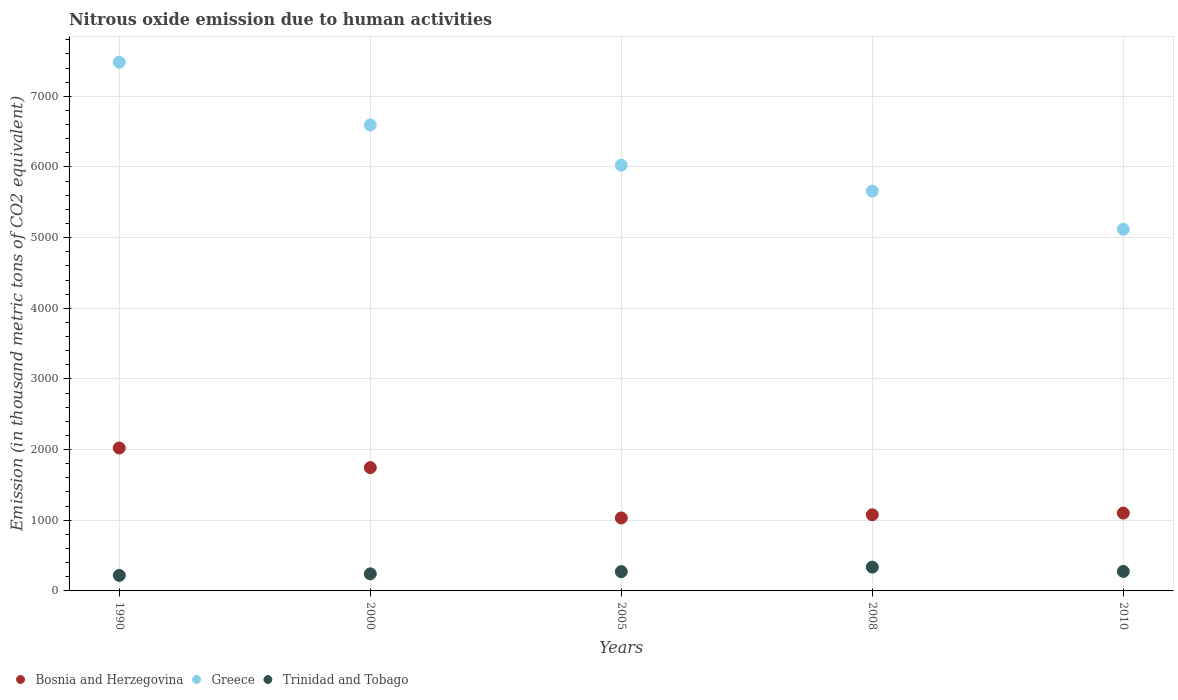How many different coloured dotlines are there?
Your answer should be compact. 3. Is the number of dotlines equal to the number of legend labels?
Make the answer very short. Yes. What is the amount of nitrous oxide emitted in Greece in 2000?
Your response must be concise. 6594. Across all years, what is the maximum amount of nitrous oxide emitted in Trinidad and Tobago?
Ensure brevity in your answer.  336.8. Across all years, what is the minimum amount of nitrous oxide emitted in Bosnia and Herzegovina?
Your answer should be compact. 1032.3. In which year was the amount of nitrous oxide emitted in Trinidad and Tobago minimum?
Keep it short and to the point. 1990. What is the total amount of nitrous oxide emitted in Trinidad and Tobago in the graph?
Provide a succinct answer. 1346.8. What is the difference between the amount of nitrous oxide emitted in Trinidad and Tobago in 1990 and that in 2008?
Provide a short and direct response. -116.9. What is the difference between the amount of nitrous oxide emitted in Trinidad and Tobago in 1990 and the amount of nitrous oxide emitted in Bosnia and Herzegovina in 2000?
Your answer should be very brief. -1525. What is the average amount of nitrous oxide emitted in Bosnia and Herzegovina per year?
Provide a short and direct response. 1395.78. In the year 2005, what is the difference between the amount of nitrous oxide emitted in Bosnia and Herzegovina and amount of nitrous oxide emitted in Trinidad and Tobago?
Your answer should be compact. 759.5. In how many years, is the amount of nitrous oxide emitted in Trinidad and Tobago greater than 7600 thousand metric tons?
Your answer should be compact. 0. What is the ratio of the amount of nitrous oxide emitted in Trinidad and Tobago in 2005 to that in 2010?
Give a very brief answer. 0.99. Is the amount of nitrous oxide emitted in Bosnia and Herzegovina in 2008 less than that in 2010?
Ensure brevity in your answer.  Yes. Is the difference between the amount of nitrous oxide emitted in Bosnia and Herzegovina in 1990 and 2008 greater than the difference between the amount of nitrous oxide emitted in Trinidad and Tobago in 1990 and 2008?
Give a very brief answer. Yes. What is the difference between the highest and the second highest amount of nitrous oxide emitted in Bosnia and Herzegovina?
Keep it short and to the point. 277.7. What is the difference between the highest and the lowest amount of nitrous oxide emitted in Greece?
Your response must be concise. 2364.4. In how many years, is the amount of nitrous oxide emitted in Trinidad and Tobago greater than the average amount of nitrous oxide emitted in Trinidad and Tobago taken over all years?
Make the answer very short. 3. Is the amount of nitrous oxide emitted in Bosnia and Herzegovina strictly greater than the amount of nitrous oxide emitted in Greece over the years?
Offer a very short reply. No. How many dotlines are there?
Keep it short and to the point. 3. How many years are there in the graph?
Ensure brevity in your answer.  5. What is the difference between two consecutive major ticks on the Y-axis?
Your answer should be very brief. 1000. Are the values on the major ticks of Y-axis written in scientific E-notation?
Your answer should be compact. No. Does the graph contain grids?
Your answer should be very brief. Yes. How are the legend labels stacked?
Offer a terse response. Horizontal. What is the title of the graph?
Provide a short and direct response. Nitrous oxide emission due to human activities. Does "Monaco" appear as one of the legend labels in the graph?
Make the answer very short. No. What is the label or title of the Y-axis?
Keep it short and to the point. Emission (in thousand metric tons of CO2 equivalent). What is the Emission (in thousand metric tons of CO2 equivalent) of Bosnia and Herzegovina in 1990?
Keep it short and to the point. 2022.6. What is the Emission (in thousand metric tons of CO2 equivalent) in Greece in 1990?
Give a very brief answer. 7482.2. What is the Emission (in thousand metric tons of CO2 equivalent) in Trinidad and Tobago in 1990?
Offer a terse response. 219.9. What is the Emission (in thousand metric tons of CO2 equivalent) of Bosnia and Herzegovina in 2000?
Provide a succinct answer. 1744.9. What is the Emission (in thousand metric tons of CO2 equivalent) of Greece in 2000?
Offer a terse response. 6594. What is the Emission (in thousand metric tons of CO2 equivalent) of Trinidad and Tobago in 2000?
Your answer should be very brief. 241.5. What is the Emission (in thousand metric tons of CO2 equivalent) in Bosnia and Herzegovina in 2005?
Ensure brevity in your answer.  1032.3. What is the Emission (in thousand metric tons of CO2 equivalent) of Greece in 2005?
Ensure brevity in your answer.  6025. What is the Emission (in thousand metric tons of CO2 equivalent) of Trinidad and Tobago in 2005?
Your answer should be compact. 272.8. What is the Emission (in thousand metric tons of CO2 equivalent) of Bosnia and Herzegovina in 2008?
Offer a very short reply. 1077.6. What is the Emission (in thousand metric tons of CO2 equivalent) in Greece in 2008?
Make the answer very short. 5657.7. What is the Emission (in thousand metric tons of CO2 equivalent) in Trinidad and Tobago in 2008?
Your answer should be very brief. 336.8. What is the Emission (in thousand metric tons of CO2 equivalent) of Bosnia and Herzegovina in 2010?
Ensure brevity in your answer.  1101.5. What is the Emission (in thousand metric tons of CO2 equivalent) of Greece in 2010?
Provide a short and direct response. 5117.8. What is the Emission (in thousand metric tons of CO2 equivalent) of Trinidad and Tobago in 2010?
Your response must be concise. 275.8. Across all years, what is the maximum Emission (in thousand metric tons of CO2 equivalent) of Bosnia and Herzegovina?
Keep it short and to the point. 2022.6. Across all years, what is the maximum Emission (in thousand metric tons of CO2 equivalent) of Greece?
Keep it short and to the point. 7482.2. Across all years, what is the maximum Emission (in thousand metric tons of CO2 equivalent) of Trinidad and Tobago?
Your response must be concise. 336.8. Across all years, what is the minimum Emission (in thousand metric tons of CO2 equivalent) of Bosnia and Herzegovina?
Make the answer very short. 1032.3. Across all years, what is the minimum Emission (in thousand metric tons of CO2 equivalent) of Greece?
Give a very brief answer. 5117.8. Across all years, what is the minimum Emission (in thousand metric tons of CO2 equivalent) of Trinidad and Tobago?
Offer a very short reply. 219.9. What is the total Emission (in thousand metric tons of CO2 equivalent) in Bosnia and Herzegovina in the graph?
Provide a succinct answer. 6978.9. What is the total Emission (in thousand metric tons of CO2 equivalent) in Greece in the graph?
Give a very brief answer. 3.09e+04. What is the total Emission (in thousand metric tons of CO2 equivalent) in Trinidad and Tobago in the graph?
Provide a succinct answer. 1346.8. What is the difference between the Emission (in thousand metric tons of CO2 equivalent) of Bosnia and Herzegovina in 1990 and that in 2000?
Your answer should be very brief. 277.7. What is the difference between the Emission (in thousand metric tons of CO2 equivalent) in Greece in 1990 and that in 2000?
Your response must be concise. 888.2. What is the difference between the Emission (in thousand metric tons of CO2 equivalent) in Trinidad and Tobago in 1990 and that in 2000?
Offer a terse response. -21.6. What is the difference between the Emission (in thousand metric tons of CO2 equivalent) in Bosnia and Herzegovina in 1990 and that in 2005?
Keep it short and to the point. 990.3. What is the difference between the Emission (in thousand metric tons of CO2 equivalent) of Greece in 1990 and that in 2005?
Offer a terse response. 1457.2. What is the difference between the Emission (in thousand metric tons of CO2 equivalent) of Trinidad and Tobago in 1990 and that in 2005?
Your answer should be compact. -52.9. What is the difference between the Emission (in thousand metric tons of CO2 equivalent) of Bosnia and Herzegovina in 1990 and that in 2008?
Give a very brief answer. 945. What is the difference between the Emission (in thousand metric tons of CO2 equivalent) of Greece in 1990 and that in 2008?
Keep it short and to the point. 1824.5. What is the difference between the Emission (in thousand metric tons of CO2 equivalent) of Trinidad and Tobago in 1990 and that in 2008?
Give a very brief answer. -116.9. What is the difference between the Emission (in thousand metric tons of CO2 equivalent) in Bosnia and Herzegovina in 1990 and that in 2010?
Provide a succinct answer. 921.1. What is the difference between the Emission (in thousand metric tons of CO2 equivalent) in Greece in 1990 and that in 2010?
Make the answer very short. 2364.4. What is the difference between the Emission (in thousand metric tons of CO2 equivalent) in Trinidad and Tobago in 1990 and that in 2010?
Give a very brief answer. -55.9. What is the difference between the Emission (in thousand metric tons of CO2 equivalent) of Bosnia and Herzegovina in 2000 and that in 2005?
Keep it short and to the point. 712.6. What is the difference between the Emission (in thousand metric tons of CO2 equivalent) in Greece in 2000 and that in 2005?
Provide a succinct answer. 569. What is the difference between the Emission (in thousand metric tons of CO2 equivalent) of Trinidad and Tobago in 2000 and that in 2005?
Offer a very short reply. -31.3. What is the difference between the Emission (in thousand metric tons of CO2 equivalent) in Bosnia and Herzegovina in 2000 and that in 2008?
Your answer should be compact. 667.3. What is the difference between the Emission (in thousand metric tons of CO2 equivalent) in Greece in 2000 and that in 2008?
Offer a terse response. 936.3. What is the difference between the Emission (in thousand metric tons of CO2 equivalent) of Trinidad and Tobago in 2000 and that in 2008?
Provide a short and direct response. -95.3. What is the difference between the Emission (in thousand metric tons of CO2 equivalent) in Bosnia and Herzegovina in 2000 and that in 2010?
Provide a succinct answer. 643.4. What is the difference between the Emission (in thousand metric tons of CO2 equivalent) in Greece in 2000 and that in 2010?
Your answer should be compact. 1476.2. What is the difference between the Emission (in thousand metric tons of CO2 equivalent) in Trinidad and Tobago in 2000 and that in 2010?
Give a very brief answer. -34.3. What is the difference between the Emission (in thousand metric tons of CO2 equivalent) of Bosnia and Herzegovina in 2005 and that in 2008?
Make the answer very short. -45.3. What is the difference between the Emission (in thousand metric tons of CO2 equivalent) of Greece in 2005 and that in 2008?
Offer a terse response. 367.3. What is the difference between the Emission (in thousand metric tons of CO2 equivalent) in Trinidad and Tobago in 2005 and that in 2008?
Give a very brief answer. -64. What is the difference between the Emission (in thousand metric tons of CO2 equivalent) in Bosnia and Herzegovina in 2005 and that in 2010?
Your response must be concise. -69.2. What is the difference between the Emission (in thousand metric tons of CO2 equivalent) in Greece in 2005 and that in 2010?
Ensure brevity in your answer.  907.2. What is the difference between the Emission (in thousand metric tons of CO2 equivalent) of Trinidad and Tobago in 2005 and that in 2010?
Your answer should be very brief. -3. What is the difference between the Emission (in thousand metric tons of CO2 equivalent) of Bosnia and Herzegovina in 2008 and that in 2010?
Give a very brief answer. -23.9. What is the difference between the Emission (in thousand metric tons of CO2 equivalent) of Greece in 2008 and that in 2010?
Offer a terse response. 539.9. What is the difference between the Emission (in thousand metric tons of CO2 equivalent) in Trinidad and Tobago in 2008 and that in 2010?
Offer a terse response. 61. What is the difference between the Emission (in thousand metric tons of CO2 equivalent) of Bosnia and Herzegovina in 1990 and the Emission (in thousand metric tons of CO2 equivalent) of Greece in 2000?
Make the answer very short. -4571.4. What is the difference between the Emission (in thousand metric tons of CO2 equivalent) of Bosnia and Herzegovina in 1990 and the Emission (in thousand metric tons of CO2 equivalent) of Trinidad and Tobago in 2000?
Ensure brevity in your answer.  1781.1. What is the difference between the Emission (in thousand metric tons of CO2 equivalent) of Greece in 1990 and the Emission (in thousand metric tons of CO2 equivalent) of Trinidad and Tobago in 2000?
Your answer should be compact. 7240.7. What is the difference between the Emission (in thousand metric tons of CO2 equivalent) of Bosnia and Herzegovina in 1990 and the Emission (in thousand metric tons of CO2 equivalent) of Greece in 2005?
Make the answer very short. -4002.4. What is the difference between the Emission (in thousand metric tons of CO2 equivalent) in Bosnia and Herzegovina in 1990 and the Emission (in thousand metric tons of CO2 equivalent) in Trinidad and Tobago in 2005?
Your answer should be compact. 1749.8. What is the difference between the Emission (in thousand metric tons of CO2 equivalent) of Greece in 1990 and the Emission (in thousand metric tons of CO2 equivalent) of Trinidad and Tobago in 2005?
Offer a very short reply. 7209.4. What is the difference between the Emission (in thousand metric tons of CO2 equivalent) in Bosnia and Herzegovina in 1990 and the Emission (in thousand metric tons of CO2 equivalent) in Greece in 2008?
Provide a short and direct response. -3635.1. What is the difference between the Emission (in thousand metric tons of CO2 equivalent) of Bosnia and Herzegovina in 1990 and the Emission (in thousand metric tons of CO2 equivalent) of Trinidad and Tobago in 2008?
Your answer should be compact. 1685.8. What is the difference between the Emission (in thousand metric tons of CO2 equivalent) in Greece in 1990 and the Emission (in thousand metric tons of CO2 equivalent) in Trinidad and Tobago in 2008?
Offer a very short reply. 7145.4. What is the difference between the Emission (in thousand metric tons of CO2 equivalent) in Bosnia and Herzegovina in 1990 and the Emission (in thousand metric tons of CO2 equivalent) in Greece in 2010?
Make the answer very short. -3095.2. What is the difference between the Emission (in thousand metric tons of CO2 equivalent) in Bosnia and Herzegovina in 1990 and the Emission (in thousand metric tons of CO2 equivalent) in Trinidad and Tobago in 2010?
Your response must be concise. 1746.8. What is the difference between the Emission (in thousand metric tons of CO2 equivalent) in Greece in 1990 and the Emission (in thousand metric tons of CO2 equivalent) in Trinidad and Tobago in 2010?
Your answer should be compact. 7206.4. What is the difference between the Emission (in thousand metric tons of CO2 equivalent) in Bosnia and Herzegovina in 2000 and the Emission (in thousand metric tons of CO2 equivalent) in Greece in 2005?
Offer a terse response. -4280.1. What is the difference between the Emission (in thousand metric tons of CO2 equivalent) in Bosnia and Herzegovina in 2000 and the Emission (in thousand metric tons of CO2 equivalent) in Trinidad and Tobago in 2005?
Your answer should be very brief. 1472.1. What is the difference between the Emission (in thousand metric tons of CO2 equivalent) of Greece in 2000 and the Emission (in thousand metric tons of CO2 equivalent) of Trinidad and Tobago in 2005?
Make the answer very short. 6321.2. What is the difference between the Emission (in thousand metric tons of CO2 equivalent) in Bosnia and Herzegovina in 2000 and the Emission (in thousand metric tons of CO2 equivalent) in Greece in 2008?
Offer a terse response. -3912.8. What is the difference between the Emission (in thousand metric tons of CO2 equivalent) of Bosnia and Herzegovina in 2000 and the Emission (in thousand metric tons of CO2 equivalent) of Trinidad and Tobago in 2008?
Provide a succinct answer. 1408.1. What is the difference between the Emission (in thousand metric tons of CO2 equivalent) of Greece in 2000 and the Emission (in thousand metric tons of CO2 equivalent) of Trinidad and Tobago in 2008?
Your answer should be compact. 6257.2. What is the difference between the Emission (in thousand metric tons of CO2 equivalent) of Bosnia and Herzegovina in 2000 and the Emission (in thousand metric tons of CO2 equivalent) of Greece in 2010?
Keep it short and to the point. -3372.9. What is the difference between the Emission (in thousand metric tons of CO2 equivalent) of Bosnia and Herzegovina in 2000 and the Emission (in thousand metric tons of CO2 equivalent) of Trinidad and Tobago in 2010?
Give a very brief answer. 1469.1. What is the difference between the Emission (in thousand metric tons of CO2 equivalent) of Greece in 2000 and the Emission (in thousand metric tons of CO2 equivalent) of Trinidad and Tobago in 2010?
Ensure brevity in your answer.  6318.2. What is the difference between the Emission (in thousand metric tons of CO2 equivalent) in Bosnia and Herzegovina in 2005 and the Emission (in thousand metric tons of CO2 equivalent) in Greece in 2008?
Make the answer very short. -4625.4. What is the difference between the Emission (in thousand metric tons of CO2 equivalent) in Bosnia and Herzegovina in 2005 and the Emission (in thousand metric tons of CO2 equivalent) in Trinidad and Tobago in 2008?
Give a very brief answer. 695.5. What is the difference between the Emission (in thousand metric tons of CO2 equivalent) in Greece in 2005 and the Emission (in thousand metric tons of CO2 equivalent) in Trinidad and Tobago in 2008?
Make the answer very short. 5688.2. What is the difference between the Emission (in thousand metric tons of CO2 equivalent) of Bosnia and Herzegovina in 2005 and the Emission (in thousand metric tons of CO2 equivalent) of Greece in 2010?
Your answer should be very brief. -4085.5. What is the difference between the Emission (in thousand metric tons of CO2 equivalent) in Bosnia and Herzegovina in 2005 and the Emission (in thousand metric tons of CO2 equivalent) in Trinidad and Tobago in 2010?
Your response must be concise. 756.5. What is the difference between the Emission (in thousand metric tons of CO2 equivalent) of Greece in 2005 and the Emission (in thousand metric tons of CO2 equivalent) of Trinidad and Tobago in 2010?
Make the answer very short. 5749.2. What is the difference between the Emission (in thousand metric tons of CO2 equivalent) of Bosnia and Herzegovina in 2008 and the Emission (in thousand metric tons of CO2 equivalent) of Greece in 2010?
Provide a short and direct response. -4040.2. What is the difference between the Emission (in thousand metric tons of CO2 equivalent) in Bosnia and Herzegovina in 2008 and the Emission (in thousand metric tons of CO2 equivalent) in Trinidad and Tobago in 2010?
Offer a very short reply. 801.8. What is the difference between the Emission (in thousand metric tons of CO2 equivalent) in Greece in 2008 and the Emission (in thousand metric tons of CO2 equivalent) in Trinidad and Tobago in 2010?
Your answer should be compact. 5381.9. What is the average Emission (in thousand metric tons of CO2 equivalent) of Bosnia and Herzegovina per year?
Offer a very short reply. 1395.78. What is the average Emission (in thousand metric tons of CO2 equivalent) in Greece per year?
Keep it short and to the point. 6175.34. What is the average Emission (in thousand metric tons of CO2 equivalent) of Trinidad and Tobago per year?
Your response must be concise. 269.36. In the year 1990, what is the difference between the Emission (in thousand metric tons of CO2 equivalent) of Bosnia and Herzegovina and Emission (in thousand metric tons of CO2 equivalent) of Greece?
Ensure brevity in your answer.  -5459.6. In the year 1990, what is the difference between the Emission (in thousand metric tons of CO2 equivalent) in Bosnia and Herzegovina and Emission (in thousand metric tons of CO2 equivalent) in Trinidad and Tobago?
Make the answer very short. 1802.7. In the year 1990, what is the difference between the Emission (in thousand metric tons of CO2 equivalent) in Greece and Emission (in thousand metric tons of CO2 equivalent) in Trinidad and Tobago?
Your response must be concise. 7262.3. In the year 2000, what is the difference between the Emission (in thousand metric tons of CO2 equivalent) of Bosnia and Herzegovina and Emission (in thousand metric tons of CO2 equivalent) of Greece?
Keep it short and to the point. -4849.1. In the year 2000, what is the difference between the Emission (in thousand metric tons of CO2 equivalent) in Bosnia and Herzegovina and Emission (in thousand metric tons of CO2 equivalent) in Trinidad and Tobago?
Your answer should be very brief. 1503.4. In the year 2000, what is the difference between the Emission (in thousand metric tons of CO2 equivalent) of Greece and Emission (in thousand metric tons of CO2 equivalent) of Trinidad and Tobago?
Your response must be concise. 6352.5. In the year 2005, what is the difference between the Emission (in thousand metric tons of CO2 equivalent) in Bosnia and Herzegovina and Emission (in thousand metric tons of CO2 equivalent) in Greece?
Offer a very short reply. -4992.7. In the year 2005, what is the difference between the Emission (in thousand metric tons of CO2 equivalent) of Bosnia and Herzegovina and Emission (in thousand metric tons of CO2 equivalent) of Trinidad and Tobago?
Make the answer very short. 759.5. In the year 2005, what is the difference between the Emission (in thousand metric tons of CO2 equivalent) of Greece and Emission (in thousand metric tons of CO2 equivalent) of Trinidad and Tobago?
Make the answer very short. 5752.2. In the year 2008, what is the difference between the Emission (in thousand metric tons of CO2 equivalent) of Bosnia and Herzegovina and Emission (in thousand metric tons of CO2 equivalent) of Greece?
Your answer should be compact. -4580.1. In the year 2008, what is the difference between the Emission (in thousand metric tons of CO2 equivalent) in Bosnia and Herzegovina and Emission (in thousand metric tons of CO2 equivalent) in Trinidad and Tobago?
Keep it short and to the point. 740.8. In the year 2008, what is the difference between the Emission (in thousand metric tons of CO2 equivalent) of Greece and Emission (in thousand metric tons of CO2 equivalent) of Trinidad and Tobago?
Your answer should be compact. 5320.9. In the year 2010, what is the difference between the Emission (in thousand metric tons of CO2 equivalent) of Bosnia and Herzegovina and Emission (in thousand metric tons of CO2 equivalent) of Greece?
Offer a terse response. -4016.3. In the year 2010, what is the difference between the Emission (in thousand metric tons of CO2 equivalent) of Bosnia and Herzegovina and Emission (in thousand metric tons of CO2 equivalent) of Trinidad and Tobago?
Make the answer very short. 825.7. In the year 2010, what is the difference between the Emission (in thousand metric tons of CO2 equivalent) in Greece and Emission (in thousand metric tons of CO2 equivalent) in Trinidad and Tobago?
Provide a succinct answer. 4842. What is the ratio of the Emission (in thousand metric tons of CO2 equivalent) in Bosnia and Herzegovina in 1990 to that in 2000?
Provide a succinct answer. 1.16. What is the ratio of the Emission (in thousand metric tons of CO2 equivalent) of Greece in 1990 to that in 2000?
Provide a succinct answer. 1.13. What is the ratio of the Emission (in thousand metric tons of CO2 equivalent) of Trinidad and Tobago in 1990 to that in 2000?
Ensure brevity in your answer.  0.91. What is the ratio of the Emission (in thousand metric tons of CO2 equivalent) of Bosnia and Herzegovina in 1990 to that in 2005?
Your answer should be compact. 1.96. What is the ratio of the Emission (in thousand metric tons of CO2 equivalent) in Greece in 1990 to that in 2005?
Make the answer very short. 1.24. What is the ratio of the Emission (in thousand metric tons of CO2 equivalent) in Trinidad and Tobago in 1990 to that in 2005?
Provide a succinct answer. 0.81. What is the ratio of the Emission (in thousand metric tons of CO2 equivalent) of Bosnia and Herzegovina in 1990 to that in 2008?
Provide a short and direct response. 1.88. What is the ratio of the Emission (in thousand metric tons of CO2 equivalent) of Greece in 1990 to that in 2008?
Your answer should be very brief. 1.32. What is the ratio of the Emission (in thousand metric tons of CO2 equivalent) of Trinidad and Tobago in 1990 to that in 2008?
Provide a succinct answer. 0.65. What is the ratio of the Emission (in thousand metric tons of CO2 equivalent) of Bosnia and Herzegovina in 1990 to that in 2010?
Provide a short and direct response. 1.84. What is the ratio of the Emission (in thousand metric tons of CO2 equivalent) of Greece in 1990 to that in 2010?
Offer a terse response. 1.46. What is the ratio of the Emission (in thousand metric tons of CO2 equivalent) in Trinidad and Tobago in 1990 to that in 2010?
Provide a short and direct response. 0.8. What is the ratio of the Emission (in thousand metric tons of CO2 equivalent) of Bosnia and Herzegovina in 2000 to that in 2005?
Provide a short and direct response. 1.69. What is the ratio of the Emission (in thousand metric tons of CO2 equivalent) in Greece in 2000 to that in 2005?
Offer a terse response. 1.09. What is the ratio of the Emission (in thousand metric tons of CO2 equivalent) in Trinidad and Tobago in 2000 to that in 2005?
Your answer should be compact. 0.89. What is the ratio of the Emission (in thousand metric tons of CO2 equivalent) of Bosnia and Herzegovina in 2000 to that in 2008?
Keep it short and to the point. 1.62. What is the ratio of the Emission (in thousand metric tons of CO2 equivalent) in Greece in 2000 to that in 2008?
Your answer should be very brief. 1.17. What is the ratio of the Emission (in thousand metric tons of CO2 equivalent) of Trinidad and Tobago in 2000 to that in 2008?
Provide a short and direct response. 0.72. What is the ratio of the Emission (in thousand metric tons of CO2 equivalent) of Bosnia and Herzegovina in 2000 to that in 2010?
Give a very brief answer. 1.58. What is the ratio of the Emission (in thousand metric tons of CO2 equivalent) of Greece in 2000 to that in 2010?
Your answer should be compact. 1.29. What is the ratio of the Emission (in thousand metric tons of CO2 equivalent) of Trinidad and Tobago in 2000 to that in 2010?
Your response must be concise. 0.88. What is the ratio of the Emission (in thousand metric tons of CO2 equivalent) of Bosnia and Herzegovina in 2005 to that in 2008?
Your answer should be compact. 0.96. What is the ratio of the Emission (in thousand metric tons of CO2 equivalent) of Greece in 2005 to that in 2008?
Keep it short and to the point. 1.06. What is the ratio of the Emission (in thousand metric tons of CO2 equivalent) of Trinidad and Tobago in 2005 to that in 2008?
Ensure brevity in your answer.  0.81. What is the ratio of the Emission (in thousand metric tons of CO2 equivalent) in Bosnia and Herzegovina in 2005 to that in 2010?
Your answer should be compact. 0.94. What is the ratio of the Emission (in thousand metric tons of CO2 equivalent) of Greece in 2005 to that in 2010?
Your answer should be very brief. 1.18. What is the ratio of the Emission (in thousand metric tons of CO2 equivalent) of Trinidad and Tobago in 2005 to that in 2010?
Keep it short and to the point. 0.99. What is the ratio of the Emission (in thousand metric tons of CO2 equivalent) of Bosnia and Herzegovina in 2008 to that in 2010?
Keep it short and to the point. 0.98. What is the ratio of the Emission (in thousand metric tons of CO2 equivalent) of Greece in 2008 to that in 2010?
Provide a short and direct response. 1.11. What is the ratio of the Emission (in thousand metric tons of CO2 equivalent) of Trinidad and Tobago in 2008 to that in 2010?
Offer a very short reply. 1.22. What is the difference between the highest and the second highest Emission (in thousand metric tons of CO2 equivalent) of Bosnia and Herzegovina?
Your answer should be compact. 277.7. What is the difference between the highest and the second highest Emission (in thousand metric tons of CO2 equivalent) of Greece?
Your response must be concise. 888.2. What is the difference between the highest and the lowest Emission (in thousand metric tons of CO2 equivalent) of Bosnia and Herzegovina?
Make the answer very short. 990.3. What is the difference between the highest and the lowest Emission (in thousand metric tons of CO2 equivalent) in Greece?
Make the answer very short. 2364.4. What is the difference between the highest and the lowest Emission (in thousand metric tons of CO2 equivalent) of Trinidad and Tobago?
Your response must be concise. 116.9. 